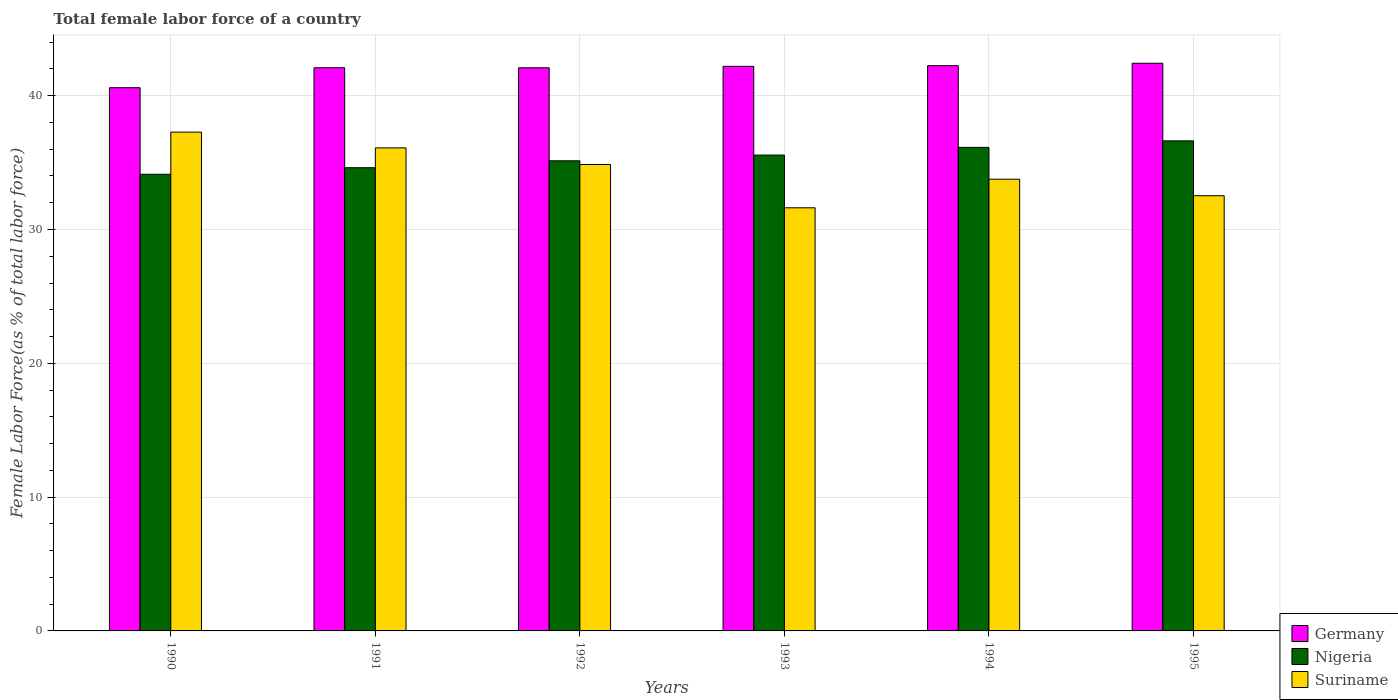How many different coloured bars are there?
Offer a very short reply. 3. Are the number of bars on each tick of the X-axis equal?
Your answer should be very brief. Yes. How many bars are there on the 3rd tick from the left?
Keep it short and to the point. 3. What is the label of the 2nd group of bars from the left?
Make the answer very short. 1991. What is the percentage of female labor force in Nigeria in 1995?
Ensure brevity in your answer.  36.62. Across all years, what is the maximum percentage of female labor force in Germany?
Provide a short and direct response. 42.42. Across all years, what is the minimum percentage of female labor force in Nigeria?
Provide a short and direct response. 34.13. In which year was the percentage of female labor force in Suriname minimum?
Your answer should be very brief. 1993. What is the total percentage of female labor force in Nigeria in the graph?
Offer a terse response. 212.21. What is the difference between the percentage of female labor force in Suriname in 1993 and that in 1995?
Offer a terse response. -0.9. What is the difference between the percentage of female labor force in Nigeria in 1995 and the percentage of female labor force in Germany in 1990?
Ensure brevity in your answer.  -3.97. What is the average percentage of female labor force in Suriname per year?
Your answer should be compact. 34.36. In the year 1990, what is the difference between the percentage of female labor force in Nigeria and percentage of female labor force in Suriname?
Ensure brevity in your answer.  -3.15. In how many years, is the percentage of female labor force in Germany greater than 28 %?
Give a very brief answer. 6. What is the ratio of the percentage of female labor force in Nigeria in 1991 to that in 1994?
Provide a succinct answer. 0.96. Is the difference between the percentage of female labor force in Nigeria in 1990 and 1994 greater than the difference between the percentage of female labor force in Suriname in 1990 and 1994?
Your answer should be very brief. No. What is the difference between the highest and the second highest percentage of female labor force in Germany?
Provide a short and direct response. 0.18. What is the difference between the highest and the lowest percentage of female labor force in Nigeria?
Make the answer very short. 2.5. In how many years, is the percentage of female labor force in Germany greater than the average percentage of female labor force in Germany taken over all years?
Your answer should be compact. 5. Is the sum of the percentage of female labor force in Suriname in 1993 and 1995 greater than the maximum percentage of female labor force in Germany across all years?
Your answer should be compact. Yes. What does the 3rd bar from the right in 1991 represents?
Provide a short and direct response. Germany. Is it the case that in every year, the sum of the percentage of female labor force in Nigeria and percentage of female labor force in Germany is greater than the percentage of female labor force in Suriname?
Provide a succinct answer. Yes. How many bars are there?
Provide a succinct answer. 18. What is the difference between two consecutive major ticks on the Y-axis?
Your answer should be compact. 10. Are the values on the major ticks of Y-axis written in scientific E-notation?
Your answer should be compact. No. Does the graph contain grids?
Give a very brief answer. Yes. What is the title of the graph?
Provide a succinct answer. Total female labor force of a country. Does "Latvia" appear as one of the legend labels in the graph?
Offer a terse response. No. What is the label or title of the Y-axis?
Give a very brief answer. Female Labor Force(as % of total labor force). What is the Female Labor Force(as % of total labor force) in Germany in 1990?
Give a very brief answer. 40.6. What is the Female Labor Force(as % of total labor force) in Nigeria in 1990?
Keep it short and to the point. 34.13. What is the Female Labor Force(as % of total labor force) of Suriname in 1990?
Provide a short and direct response. 37.28. What is the Female Labor Force(as % of total labor force) in Germany in 1991?
Ensure brevity in your answer.  42.09. What is the Female Labor Force(as % of total labor force) in Nigeria in 1991?
Make the answer very short. 34.62. What is the Female Labor Force(as % of total labor force) in Suriname in 1991?
Your answer should be very brief. 36.1. What is the Female Labor Force(as % of total labor force) in Germany in 1992?
Keep it short and to the point. 42.09. What is the Female Labor Force(as % of total labor force) of Nigeria in 1992?
Offer a terse response. 35.13. What is the Female Labor Force(as % of total labor force) in Suriname in 1992?
Keep it short and to the point. 34.86. What is the Female Labor Force(as % of total labor force) in Germany in 1993?
Offer a terse response. 42.2. What is the Female Labor Force(as % of total labor force) in Nigeria in 1993?
Offer a very short reply. 35.56. What is the Female Labor Force(as % of total labor force) in Suriname in 1993?
Give a very brief answer. 31.62. What is the Female Labor Force(as % of total labor force) in Germany in 1994?
Your answer should be very brief. 42.24. What is the Female Labor Force(as % of total labor force) of Nigeria in 1994?
Your answer should be very brief. 36.14. What is the Female Labor Force(as % of total labor force) in Suriname in 1994?
Provide a succinct answer. 33.76. What is the Female Labor Force(as % of total labor force) of Germany in 1995?
Provide a succinct answer. 42.42. What is the Female Labor Force(as % of total labor force) of Nigeria in 1995?
Your answer should be very brief. 36.62. What is the Female Labor Force(as % of total labor force) in Suriname in 1995?
Keep it short and to the point. 32.53. Across all years, what is the maximum Female Labor Force(as % of total labor force) of Germany?
Your answer should be compact. 42.42. Across all years, what is the maximum Female Labor Force(as % of total labor force) of Nigeria?
Provide a short and direct response. 36.62. Across all years, what is the maximum Female Labor Force(as % of total labor force) in Suriname?
Provide a succinct answer. 37.28. Across all years, what is the minimum Female Labor Force(as % of total labor force) of Germany?
Offer a terse response. 40.6. Across all years, what is the minimum Female Labor Force(as % of total labor force) in Nigeria?
Offer a terse response. 34.13. Across all years, what is the minimum Female Labor Force(as % of total labor force) in Suriname?
Give a very brief answer. 31.62. What is the total Female Labor Force(as % of total labor force) in Germany in the graph?
Your response must be concise. 251.64. What is the total Female Labor Force(as % of total labor force) of Nigeria in the graph?
Provide a succinct answer. 212.21. What is the total Female Labor Force(as % of total labor force) in Suriname in the graph?
Your response must be concise. 206.15. What is the difference between the Female Labor Force(as % of total labor force) of Germany in 1990 and that in 1991?
Your answer should be very brief. -1.49. What is the difference between the Female Labor Force(as % of total labor force) in Nigeria in 1990 and that in 1991?
Provide a succinct answer. -0.49. What is the difference between the Female Labor Force(as % of total labor force) in Suriname in 1990 and that in 1991?
Ensure brevity in your answer.  1.18. What is the difference between the Female Labor Force(as % of total labor force) of Germany in 1990 and that in 1992?
Your answer should be very brief. -1.49. What is the difference between the Female Labor Force(as % of total labor force) of Nigeria in 1990 and that in 1992?
Offer a terse response. -1.01. What is the difference between the Female Labor Force(as % of total labor force) of Suriname in 1990 and that in 1992?
Give a very brief answer. 2.42. What is the difference between the Female Labor Force(as % of total labor force) in Germany in 1990 and that in 1993?
Your response must be concise. -1.6. What is the difference between the Female Labor Force(as % of total labor force) in Nigeria in 1990 and that in 1993?
Give a very brief answer. -1.43. What is the difference between the Female Labor Force(as % of total labor force) of Suriname in 1990 and that in 1993?
Your answer should be compact. 5.66. What is the difference between the Female Labor Force(as % of total labor force) in Germany in 1990 and that in 1994?
Ensure brevity in your answer.  -1.65. What is the difference between the Female Labor Force(as % of total labor force) in Nigeria in 1990 and that in 1994?
Ensure brevity in your answer.  -2.01. What is the difference between the Female Labor Force(as % of total labor force) of Suriname in 1990 and that in 1994?
Offer a very short reply. 3.52. What is the difference between the Female Labor Force(as % of total labor force) of Germany in 1990 and that in 1995?
Provide a succinct answer. -1.83. What is the difference between the Female Labor Force(as % of total labor force) in Nigeria in 1990 and that in 1995?
Ensure brevity in your answer.  -2.5. What is the difference between the Female Labor Force(as % of total labor force) in Suriname in 1990 and that in 1995?
Your response must be concise. 4.75. What is the difference between the Female Labor Force(as % of total labor force) in Germany in 1991 and that in 1992?
Provide a short and direct response. 0. What is the difference between the Female Labor Force(as % of total labor force) in Nigeria in 1991 and that in 1992?
Your answer should be very brief. -0.52. What is the difference between the Female Labor Force(as % of total labor force) of Suriname in 1991 and that in 1992?
Keep it short and to the point. 1.24. What is the difference between the Female Labor Force(as % of total labor force) of Germany in 1991 and that in 1993?
Your answer should be compact. -0.11. What is the difference between the Female Labor Force(as % of total labor force) in Nigeria in 1991 and that in 1993?
Give a very brief answer. -0.94. What is the difference between the Female Labor Force(as % of total labor force) of Suriname in 1991 and that in 1993?
Provide a short and direct response. 4.48. What is the difference between the Female Labor Force(as % of total labor force) in Germany in 1991 and that in 1994?
Offer a very short reply. -0.15. What is the difference between the Female Labor Force(as % of total labor force) of Nigeria in 1991 and that in 1994?
Provide a succinct answer. -1.52. What is the difference between the Female Labor Force(as % of total labor force) in Suriname in 1991 and that in 1994?
Provide a short and direct response. 2.34. What is the difference between the Female Labor Force(as % of total labor force) of Germany in 1991 and that in 1995?
Provide a short and direct response. -0.34. What is the difference between the Female Labor Force(as % of total labor force) in Nigeria in 1991 and that in 1995?
Provide a short and direct response. -2.01. What is the difference between the Female Labor Force(as % of total labor force) in Suriname in 1991 and that in 1995?
Offer a terse response. 3.58. What is the difference between the Female Labor Force(as % of total labor force) of Germany in 1992 and that in 1993?
Your answer should be compact. -0.11. What is the difference between the Female Labor Force(as % of total labor force) in Nigeria in 1992 and that in 1993?
Your answer should be compact. -0.43. What is the difference between the Female Labor Force(as % of total labor force) in Suriname in 1992 and that in 1993?
Your answer should be very brief. 3.24. What is the difference between the Female Labor Force(as % of total labor force) of Germany in 1992 and that in 1994?
Ensure brevity in your answer.  -0.16. What is the difference between the Female Labor Force(as % of total labor force) in Nigeria in 1992 and that in 1994?
Offer a very short reply. -1. What is the difference between the Female Labor Force(as % of total labor force) of Suriname in 1992 and that in 1994?
Provide a succinct answer. 1.1. What is the difference between the Female Labor Force(as % of total labor force) of Germany in 1992 and that in 1995?
Offer a very short reply. -0.34. What is the difference between the Female Labor Force(as % of total labor force) in Nigeria in 1992 and that in 1995?
Offer a very short reply. -1.49. What is the difference between the Female Labor Force(as % of total labor force) in Suriname in 1992 and that in 1995?
Ensure brevity in your answer.  2.33. What is the difference between the Female Labor Force(as % of total labor force) in Germany in 1993 and that in 1994?
Offer a terse response. -0.05. What is the difference between the Female Labor Force(as % of total labor force) in Nigeria in 1993 and that in 1994?
Provide a succinct answer. -0.58. What is the difference between the Female Labor Force(as % of total labor force) in Suriname in 1993 and that in 1994?
Give a very brief answer. -2.14. What is the difference between the Female Labor Force(as % of total labor force) in Germany in 1993 and that in 1995?
Your answer should be very brief. -0.23. What is the difference between the Female Labor Force(as % of total labor force) in Nigeria in 1993 and that in 1995?
Provide a short and direct response. -1.06. What is the difference between the Female Labor Force(as % of total labor force) of Suriname in 1993 and that in 1995?
Ensure brevity in your answer.  -0.9. What is the difference between the Female Labor Force(as % of total labor force) of Germany in 1994 and that in 1995?
Provide a short and direct response. -0.18. What is the difference between the Female Labor Force(as % of total labor force) in Nigeria in 1994 and that in 1995?
Your response must be concise. -0.49. What is the difference between the Female Labor Force(as % of total labor force) in Suriname in 1994 and that in 1995?
Ensure brevity in your answer.  1.23. What is the difference between the Female Labor Force(as % of total labor force) of Germany in 1990 and the Female Labor Force(as % of total labor force) of Nigeria in 1991?
Offer a terse response. 5.98. What is the difference between the Female Labor Force(as % of total labor force) in Germany in 1990 and the Female Labor Force(as % of total labor force) in Suriname in 1991?
Ensure brevity in your answer.  4.5. What is the difference between the Female Labor Force(as % of total labor force) in Nigeria in 1990 and the Female Labor Force(as % of total labor force) in Suriname in 1991?
Your answer should be compact. -1.97. What is the difference between the Female Labor Force(as % of total labor force) of Germany in 1990 and the Female Labor Force(as % of total labor force) of Nigeria in 1992?
Make the answer very short. 5.46. What is the difference between the Female Labor Force(as % of total labor force) of Germany in 1990 and the Female Labor Force(as % of total labor force) of Suriname in 1992?
Offer a terse response. 5.74. What is the difference between the Female Labor Force(as % of total labor force) of Nigeria in 1990 and the Female Labor Force(as % of total labor force) of Suriname in 1992?
Offer a very short reply. -0.73. What is the difference between the Female Labor Force(as % of total labor force) in Germany in 1990 and the Female Labor Force(as % of total labor force) in Nigeria in 1993?
Provide a succinct answer. 5.03. What is the difference between the Female Labor Force(as % of total labor force) of Germany in 1990 and the Female Labor Force(as % of total labor force) of Suriname in 1993?
Ensure brevity in your answer.  8.97. What is the difference between the Female Labor Force(as % of total labor force) of Nigeria in 1990 and the Female Labor Force(as % of total labor force) of Suriname in 1993?
Make the answer very short. 2.51. What is the difference between the Female Labor Force(as % of total labor force) in Germany in 1990 and the Female Labor Force(as % of total labor force) in Nigeria in 1994?
Make the answer very short. 4.46. What is the difference between the Female Labor Force(as % of total labor force) in Germany in 1990 and the Female Labor Force(as % of total labor force) in Suriname in 1994?
Give a very brief answer. 6.84. What is the difference between the Female Labor Force(as % of total labor force) of Nigeria in 1990 and the Female Labor Force(as % of total labor force) of Suriname in 1994?
Keep it short and to the point. 0.37. What is the difference between the Female Labor Force(as % of total labor force) of Germany in 1990 and the Female Labor Force(as % of total labor force) of Nigeria in 1995?
Your answer should be compact. 3.97. What is the difference between the Female Labor Force(as % of total labor force) of Germany in 1990 and the Female Labor Force(as % of total labor force) of Suriname in 1995?
Your response must be concise. 8.07. What is the difference between the Female Labor Force(as % of total labor force) in Nigeria in 1990 and the Female Labor Force(as % of total labor force) in Suriname in 1995?
Your answer should be very brief. 1.6. What is the difference between the Female Labor Force(as % of total labor force) of Germany in 1991 and the Female Labor Force(as % of total labor force) of Nigeria in 1992?
Your answer should be compact. 6.95. What is the difference between the Female Labor Force(as % of total labor force) in Germany in 1991 and the Female Labor Force(as % of total labor force) in Suriname in 1992?
Your response must be concise. 7.23. What is the difference between the Female Labor Force(as % of total labor force) of Nigeria in 1991 and the Female Labor Force(as % of total labor force) of Suriname in 1992?
Your response must be concise. -0.24. What is the difference between the Female Labor Force(as % of total labor force) of Germany in 1991 and the Female Labor Force(as % of total labor force) of Nigeria in 1993?
Offer a terse response. 6.53. What is the difference between the Female Labor Force(as % of total labor force) in Germany in 1991 and the Female Labor Force(as % of total labor force) in Suriname in 1993?
Make the answer very short. 10.47. What is the difference between the Female Labor Force(as % of total labor force) in Nigeria in 1991 and the Female Labor Force(as % of total labor force) in Suriname in 1993?
Give a very brief answer. 3. What is the difference between the Female Labor Force(as % of total labor force) of Germany in 1991 and the Female Labor Force(as % of total labor force) of Nigeria in 1994?
Keep it short and to the point. 5.95. What is the difference between the Female Labor Force(as % of total labor force) in Germany in 1991 and the Female Labor Force(as % of total labor force) in Suriname in 1994?
Give a very brief answer. 8.33. What is the difference between the Female Labor Force(as % of total labor force) in Nigeria in 1991 and the Female Labor Force(as % of total labor force) in Suriname in 1994?
Keep it short and to the point. 0.86. What is the difference between the Female Labor Force(as % of total labor force) of Germany in 1991 and the Female Labor Force(as % of total labor force) of Nigeria in 1995?
Make the answer very short. 5.46. What is the difference between the Female Labor Force(as % of total labor force) in Germany in 1991 and the Female Labor Force(as % of total labor force) in Suriname in 1995?
Keep it short and to the point. 9.56. What is the difference between the Female Labor Force(as % of total labor force) in Nigeria in 1991 and the Female Labor Force(as % of total labor force) in Suriname in 1995?
Provide a succinct answer. 2.09. What is the difference between the Female Labor Force(as % of total labor force) in Germany in 1992 and the Female Labor Force(as % of total labor force) in Nigeria in 1993?
Make the answer very short. 6.52. What is the difference between the Female Labor Force(as % of total labor force) in Germany in 1992 and the Female Labor Force(as % of total labor force) in Suriname in 1993?
Your answer should be very brief. 10.46. What is the difference between the Female Labor Force(as % of total labor force) in Nigeria in 1992 and the Female Labor Force(as % of total labor force) in Suriname in 1993?
Offer a very short reply. 3.51. What is the difference between the Female Labor Force(as % of total labor force) in Germany in 1992 and the Female Labor Force(as % of total labor force) in Nigeria in 1994?
Provide a short and direct response. 5.95. What is the difference between the Female Labor Force(as % of total labor force) in Germany in 1992 and the Female Labor Force(as % of total labor force) in Suriname in 1994?
Keep it short and to the point. 8.33. What is the difference between the Female Labor Force(as % of total labor force) in Nigeria in 1992 and the Female Labor Force(as % of total labor force) in Suriname in 1994?
Ensure brevity in your answer.  1.38. What is the difference between the Female Labor Force(as % of total labor force) in Germany in 1992 and the Female Labor Force(as % of total labor force) in Nigeria in 1995?
Offer a very short reply. 5.46. What is the difference between the Female Labor Force(as % of total labor force) in Germany in 1992 and the Female Labor Force(as % of total labor force) in Suriname in 1995?
Provide a short and direct response. 9.56. What is the difference between the Female Labor Force(as % of total labor force) in Nigeria in 1992 and the Female Labor Force(as % of total labor force) in Suriname in 1995?
Your answer should be very brief. 2.61. What is the difference between the Female Labor Force(as % of total labor force) in Germany in 1993 and the Female Labor Force(as % of total labor force) in Nigeria in 1994?
Your answer should be very brief. 6.06. What is the difference between the Female Labor Force(as % of total labor force) in Germany in 1993 and the Female Labor Force(as % of total labor force) in Suriname in 1994?
Your answer should be very brief. 8.44. What is the difference between the Female Labor Force(as % of total labor force) of Nigeria in 1993 and the Female Labor Force(as % of total labor force) of Suriname in 1994?
Provide a short and direct response. 1.8. What is the difference between the Female Labor Force(as % of total labor force) of Germany in 1993 and the Female Labor Force(as % of total labor force) of Nigeria in 1995?
Your answer should be very brief. 5.57. What is the difference between the Female Labor Force(as % of total labor force) of Germany in 1993 and the Female Labor Force(as % of total labor force) of Suriname in 1995?
Offer a terse response. 9.67. What is the difference between the Female Labor Force(as % of total labor force) in Nigeria in 1993 and the Female Labor Force(as % of total labor force) in Suriname in 1995?
Offer a terse response. 3.04. What is the difference between the Female Labor Force(as % of total labor force) in Germany in 1994 and the Female Labor Force(as % of total labor force) in Nigeria in 1995?
Offer a very short reply. 5.62. What is the difference between the Female Labor Force(as % of total labor force) of Germany in 1994 and the Female Labor Force(as % of total labor force) of Suriname in 1995?
Give a very brief answer. 9.72. What is the difference between the Female Labor Force(as % of total labor force) of Nigeria in 1994 and the Female Labor Force(as % of total labor force) of Suriname in 1995?
Give a very brief answer. 3.61. What is the average Female Labor Force(as % of total labor force) of Germany per year?
Provide a short and direct response. 41.94. What is the average Female Labor Force(as % of total labor force) of Nigeria per year?
Provide a succinct answer. 35.37. What is the average Female Labor Force(as % of total labor force) of Suriname per year?
Provide a short and direct response. 34.36. In the year 1990, what is the difference between the Female Labor Force(as % of total labor force) of Germany and Female Labor Force(as % of total labor force) of Nigeria?
Your answer should be compact. 6.47. In the year 1990, what is the difference between the Female Labor Force(as % of total labor force) in Germany and Female Labor Force(as % of total labor force) in Suriname?
Your answer should be compact. 3.32. In the year 1990, what is the difference between the Female Labor Force(as % of total labor force) of Nigeria and Female Labor Force(as % of total labor force) of Suriname?
Provide a succinct answer. -3.15. In the year 1991, what is the difference between the Female Labor Force(as % of total labor force) in Germany and Female Labor Force(as % of total labor force) in Nigeria?
Your answer should be compact. 7.47. In the year 1991, what is the difference between the Female Labor Force(as % of total labor force) of Germany and Female Labor Force(as % of total labor force) of Suriname?
Provide a short and direct response. 5.99. In the year 1991, what is the difference between the Female Labor Force(as % of total labor force) in Nigeria and Female Labor Force(as % of total labor force) in Suriname?
Provide a short and direct response. -1.48. In the year 1992, what is the difference between the Female Labor Force(as % of total labor force) of Germany and Female Labor Force(as % of total labor force) of Nigeria?
Provide a short and direct response. 6.95. In the year 1992, what is the difference between the Female Labor Force(as % of total labor force) in Germany and Female Labor Force(as % of total labor force) in Suriname?
Your answer should be compact. 7.23. In the year 1992, what is the difference between the Female Labor Force(as % of total labor force) in Nigeria and Female Labor Force(as % of total labor force) in Suriname?
Your response must be concise. 0.28. In the year 1993, what is the difference between the Female Labor Force(as % of total labor force) in Germany and Female Labor Force(as % of total labor force) in Nigeria?
Offer a terse response. 6.63. In the year 1993, what is the difference between the Female Labor Force(as % of total labor force) in Germany and Female Labor Force(as % of total labor force) in Suriname?
Offer a terse response. 10.57. In the year 1993, what is the difference between the Female Labor Force(as % of total labor force) in Nigeria and Female Labor Force(as % of total labor force) in Suriname?
Make the answer very short. 3.94. In the year 1994, what is the difference between the Female Labor Force(as % of total labor force) of Germany and Female Labor Force(as % of total labor force) of Nigeria?
Provide a succinct answer. 6.11. In the year 1994, what is the difference between the Female Labor Force(as % of total labor force) of Germany and Female Labor Force(as % of total labor force) of Suriname?
Give a very brief answer. 8.48. In the year 1994, what is the difference between the Female Labor Force(as % of total labor force) of Nigeria and Female Labor Force(as % of total labor force) of Suriname?
Give a very brief answer. 2.38. In the year 1995, what is the difference between the Female Labor Force(as % of total labor force) of Germany and Female Labor Force(as % of total labor force) of Nigeria?
Your answer should be very brief. 5.8. In the year 1995, what is the difference between the Female Labor Force(as % of total labor force) of Germany and Female Labor Force(as % of total labor force) of Suriname?
Offer a very short reply. 9.9. In the year 1995, what is the difference between the Female Labor Force(as % of total labor force) of Nigeria and Female Labor Force(as % of total labor force) of Suriname?
Ensure brevity in your answer.  4.1. What is the ratio of the Female Labor Force(as % of total labor force) of Germany in 1990 to that in 1991?
Give a very brief answer. 0.96. What is the ratio of the Female Labor Force(as % of total labor force) of Nigeria in 1990 to that in 1991?
Your response must be concise. 0.99. What is the ratio of the Female Labor Force(as % of total labor force) of Suriname in 1990 to that in 1991?
Make the answer very short. 1.03. What is the ratio of the Female Labor Force(as % of total labor force) in Germany in 1990 to that in 1992?
Provide a short and direct response. 0.96. What is the ratio of the Female Labor Force(as % of total labor force) of Nigeria in 1990 to that in 1992?
Offer a terse response. 0.97. What is the ratio of the Female Labor Force(as % of total labor force) of Suriname in 1990 to that in 1992?
Provide a short and direct response. 1.07. What is the ratio of the Female Labor Force(as % of total labor force) of Germany in 1990 to that in 1993?
Ensure brevity in your answer.  0.96. What is the ratio of the Female Labor Force(as % of total labor force) of Nigeria in 1990 to that in 1993?
Offer a very short reply. 0.96. What is the ratio of the Female Labor Force(as % of total labor force) in Suriname in 1990 to that in 1993?
Your answer should be compact. 1.18. What is the ratio of the Female Labor Force(as % of total labor force) of Germany in 1990 to that in 1994?
Make the answer very short. 0.96. What is the ratio of the Female Labor Force(as % of total labor force) in Nigeria in 1990 to that in 1994?
Offer a terse response. 0.94. What is the ratio of the Female Labor Force(as % of total labor force) in Suriname in 1990 to that in 1994?
Offer a very short reply. 1.1. What is the ratio of the Female Labor Force(as % of total labor force) of Germany in 1990 to that in 1995?
Ensure brevity in your answer.  0.96. What is the ratio of the Female Labor Force(as % of total labor force) in Nigeria in 1990 to that in 1995?
Provide a short and direct response. 0.93. What is the ratio of the Female Labor Force(as % of total labor force) in Suriname in 1990 to that in 1995?
Provide a short and direct response. 1.15. What is the ratio of the Female Labor Force(as % of total labor force) in Suriname in 1991 to that in 1992?
Give a very brief answer. 1.04. What is the ratio of the Female Labor Force(as % of total labor force) of Nigeria in 1991 to that in 1993?
Give a very brief answer. 0.97. What is the ratio of the Female Labor Force(as % of total labor force) of Suriname in 1991 to that in 1993?
Keep it short and to the point. 1.14. What is the ratio of the Female Labor Force(as % of total labor force) in Nigeria in 1991 to that in 1994?
Your response must be concise. 0.96. What is the ratio of the Female Labor Force(as % of total labor force) of Suriname in 1991 to that in 1994?
Your response must be concise. 1.07. What is the ratio of the Female Labor Force(as % of total labor force) in Germany in 1991 to that in 1995?
Offer a terse response. 0.99. What is the ratio of the Female Labor Force(as % of total labor force) of Nigeria in 1991 to that in 1995?
Give a very brief answer. 0.95. What is the ratio of the Female Labor Force(as % of total labor force) of Suriname in 1991 to that in 1995?
Ensure brevity in your answer.  1.11. What is the ratio of the Female Labor Force(as % of total labor force) of Suriname in 1992 to that in 1993?
Give a very brief answer. 1.1. What is the ratio of the Female Labor Force(as % of total labor force) in Nigeria in 1992 to that in 1994?
Provide a succinct answer. 0.97. What is the ratio of the Female Labor Force(as % of total labor force) of Suriname in 1992 to that in 1994?
Give a very brief answer. 1.03. What is the ratio of the Female Labor Force(as % of total labor force) of Germany in 1992 to that in 1995?
Your answer should be very brief. 0.99. What is the ratio of the Female Labor Force(as % of total labor force) in Nigeria in 1992 to that in 1995?
Your response must be concise. 0.96. What is the ratio of the Female Labor Force(as % of total labor force) of Suriname in 1992 to that in 1995?
Your answer should be compact. 1.07. What is the ratio of the Female Labor Force(as % of total labor force) in Nigeria in 1993 to that in 1994?
Keep it short and to the point. 0.98. What is the ratio of the Female Labor Force(as % of total labor force) in Suriname in 1993 to that in 1994?
Your answer should be compact. 0.94. What is the ratio of the Female Labor Force(as % of total labor force) of Nigeria in 1993 to that in 1995?
Offer a very short reply. 0.97. What is the ratio of the Female Labor Force(as % of total labor force) in Suriname in 1993 to that in 1995?
Give a very brief answer. 0.97. What is the ratio of the Female Labor Force(as % of total labor force) of Germany in 1994 to that in 1995?
Offer a terse response. 1. What is the ratio of the Female Labor Force(as % of total labor force) of Nigeria in 1994 to that in 1995?
Provide a short and direct response. 0.99. What is the ratio of the Female Labor Force(as % of total labor force) in Suriname in 1994 to that in 1995?
Your answer should be very brief. 1.04. What is the difference between the highest and the second highest Female Labor Force(as % of total labor force) of Germany?
Give a very brief answer. 0.18. What is the difference between the highest and the second highest Female Labor Force(as % of total labor force) in Nigeria?
Offer a very short reply. 0.49. What is the difference between the highest and the second highest Female Labor Force(as % of total labor force) in Suriname?
Ensure brevity in your answer.  1.18. What is the difference between the highest and the lowest Female Labor Force(as % of total labor force) in Germany?
Keep it short and to the point. 1.83. What is the difference between the highest and the lowest Female Labor Force(as % of total labor force) in Nigeria?
Make the answer very short. 2.5. What is the difference between the highest and the lowest Female Labor Force(as % of total labor force) of Suriname?
Your response must be concise. 5.66. 